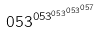<formula> <loc_0><loc_0><loc_500><loc_500>0 5 3 ^ { 0 5 3 ^ { 0 5 3 ^ { 0 5 3 ^ { 0 5 7 } } } }</formula> 